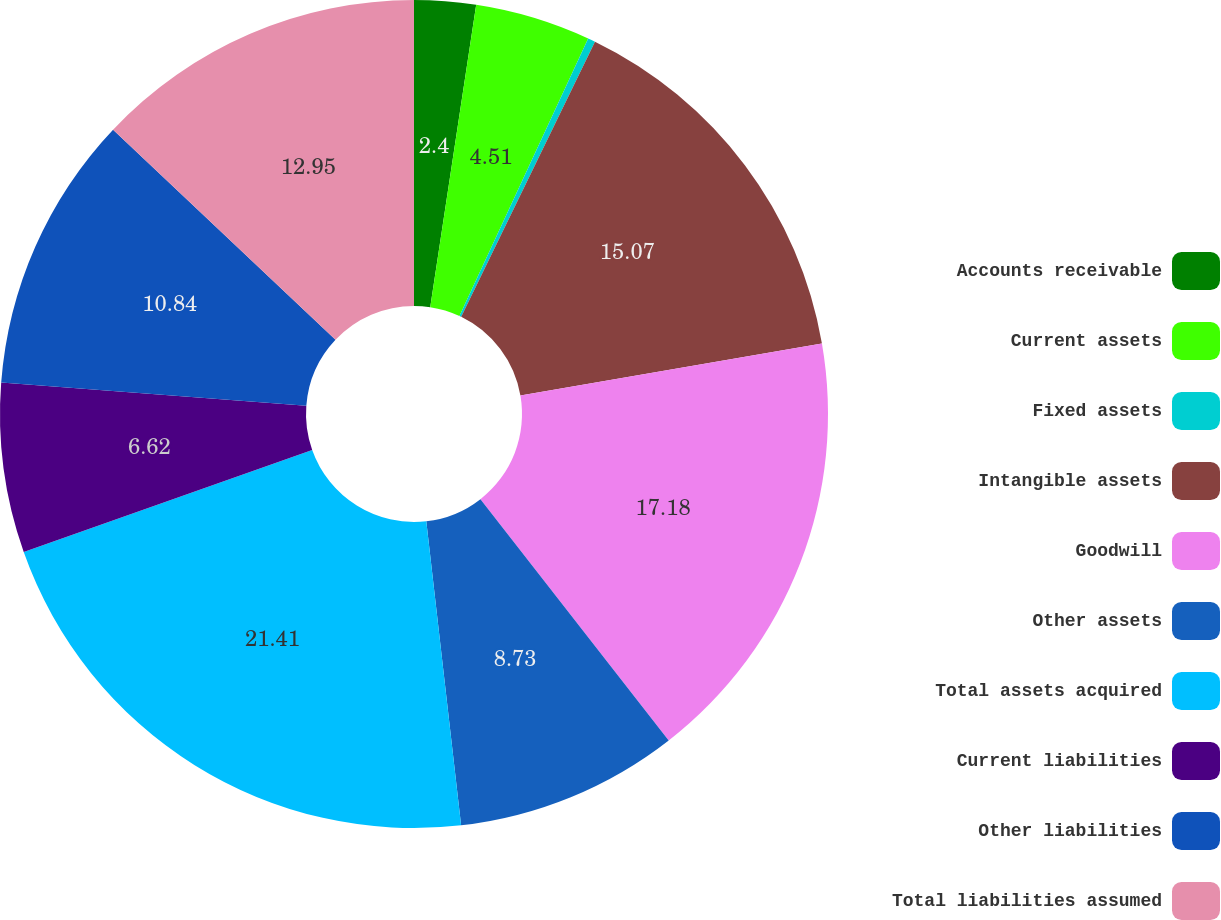Convert chart to OTSL. <chart><loc_0><loc_0><loc_500><loc_500><pie_chart><fcel>Accounts receivable<fcel>Current assets<fcel>Fixed assets<fcel>Intangible assets<fcel>Goodwill<fcel>Other assets<fcel>Total assets acquired<fcel>Current liabilities<fcel>Other liabilities<fcel>Total liabilities assumed<nl><fcel>2.4%<fcel>4.51%<fcel>0.29%<fcel>15.07%<fcel>17.18%<fcel>8.73%<fcel>21.4%<fcel>6.62%<fcel>10.84%<fcel>12.95%<nl></chart> 